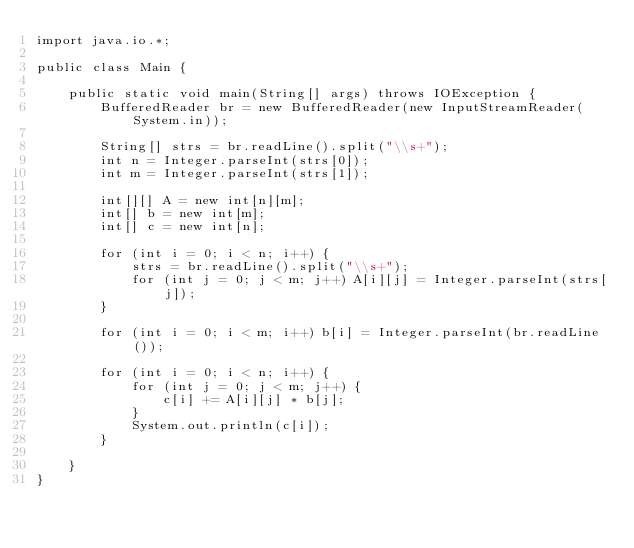Convert code to text. <code><loc_0><loc_0><loc_500><loc_500><_Java_>import java.io.*;

public class Main {

	public static void main(String[] args) throws IOException {
		BufferedReader br = new BufferedReader(new InputStreamReader(System.in));
		
		String[] strs = br.readLine().split("\\s+");
		int n = Integer.parseInt(strs[0]);
		int m = Integer.parseInt(strs[1]);

		int[][] A = new int[n][m];
		int[] b = new int[m];
		int[] c = new int[n];
		
		for (int i = 0; i < n; i++) {
			strs = br.readLine().split("\\s+");
			for (int j = 0; j < m; j++) A[i][j] = Integer.parseInt(strs[j]);
		}
		
		for (int i = 0; i < m; i++) b[i] = Integer.parseInt(br.readLine());
		
		for (int i = 0; i < n; i++) {
			for (int j = 0; j < m; j++) {
				c[i] += A[i][j] * b[j];
			}
			System.out.println(c[i]);
		}
		
	}
}</code> 